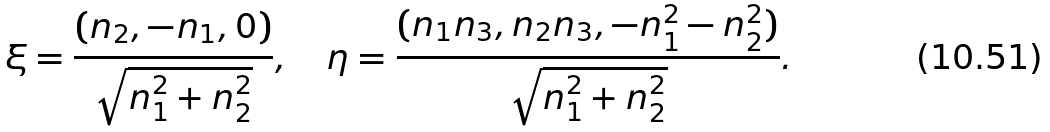Convert formula to latex. <formula><loc_0><loc_0><loc_500><loc_500>\xi = \frac { ( n _ { 2 } , - n _ { 1 } , 0 ) } { \sqrt { n _ { 1 } ^ { 2 } + n _ { 2 } ^ { 2 } } } , \quad \eta = \frac { ( n _ { 1 } n _ { 3 } , n _ { 2 } n _ { 3 } , - n _ { 1 } ^ { 2 } - n _ { 2 } ^ { 2 } ) } { \sqrt { n _ { 1 } ^ { 2 } + n _ { 2 } ^ { 2 } } } .</formula> 